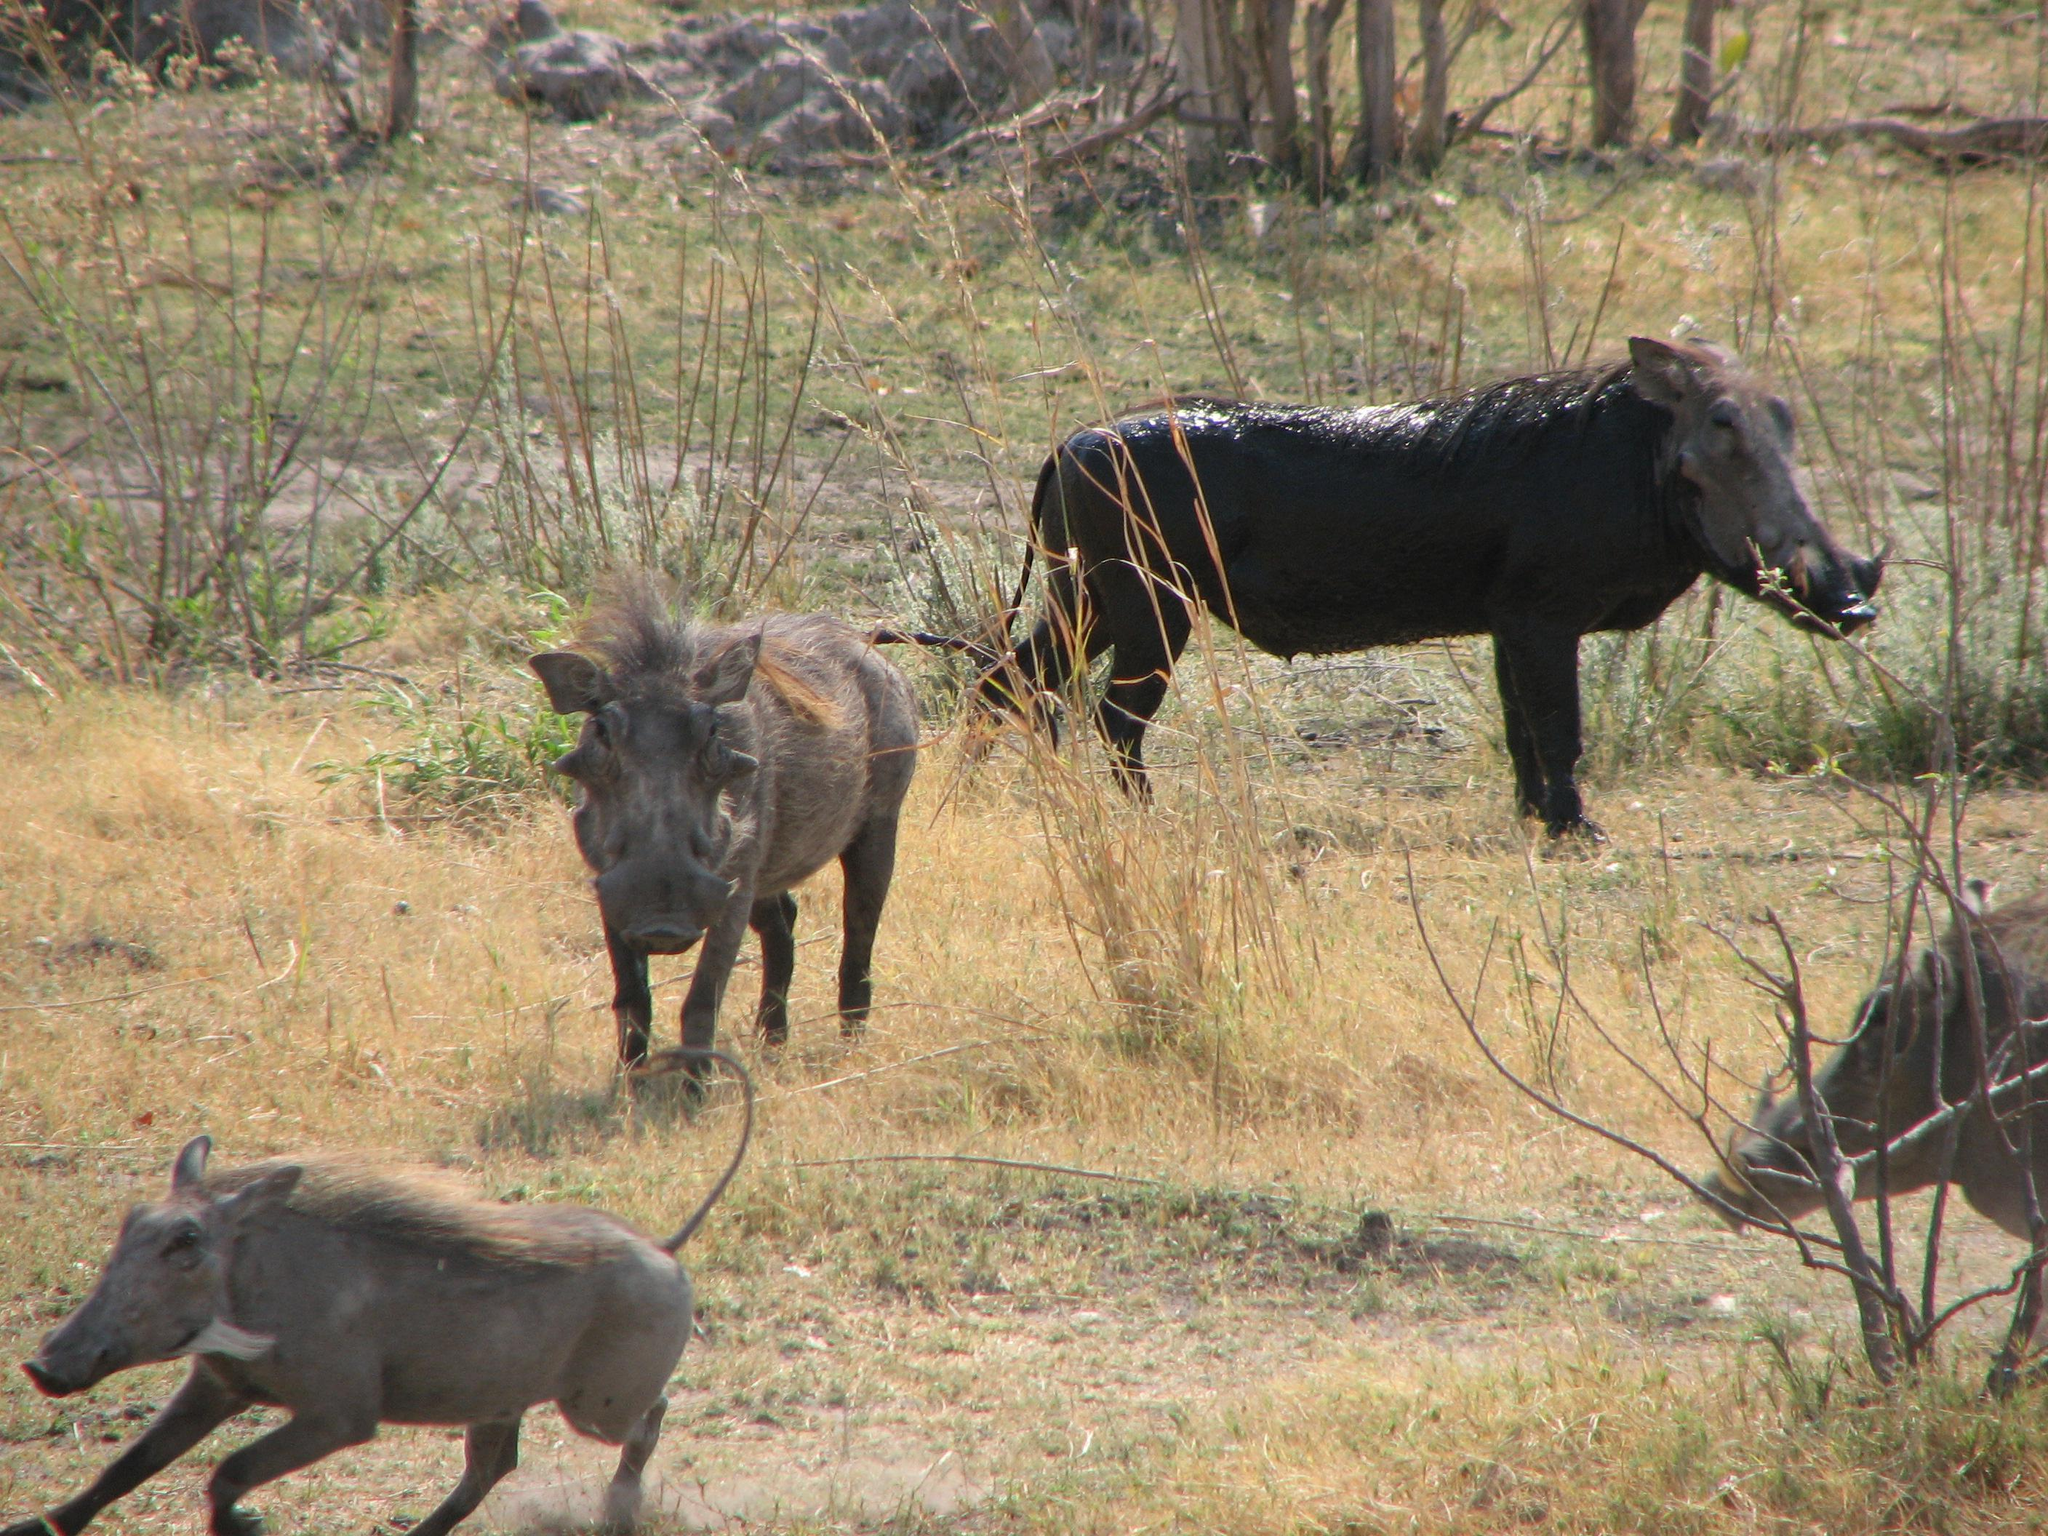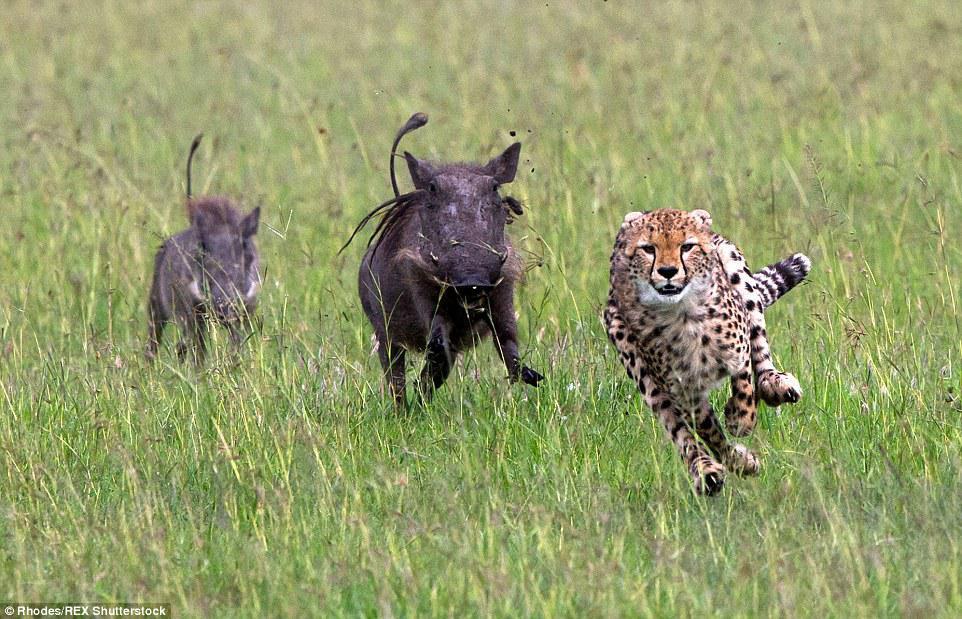The first image is the image on the left, the second image is the image on the right. Analyze the images presented: Is the assertion "An image shows warthog on the left and spotted cat on the right." valid? Answer yes or no. Yes. The first image is the image on the left, the second image is the image on the right. Considering the images on both sides, is "There is a feline in one of the images." valid? Answer yes or no. Yes. 